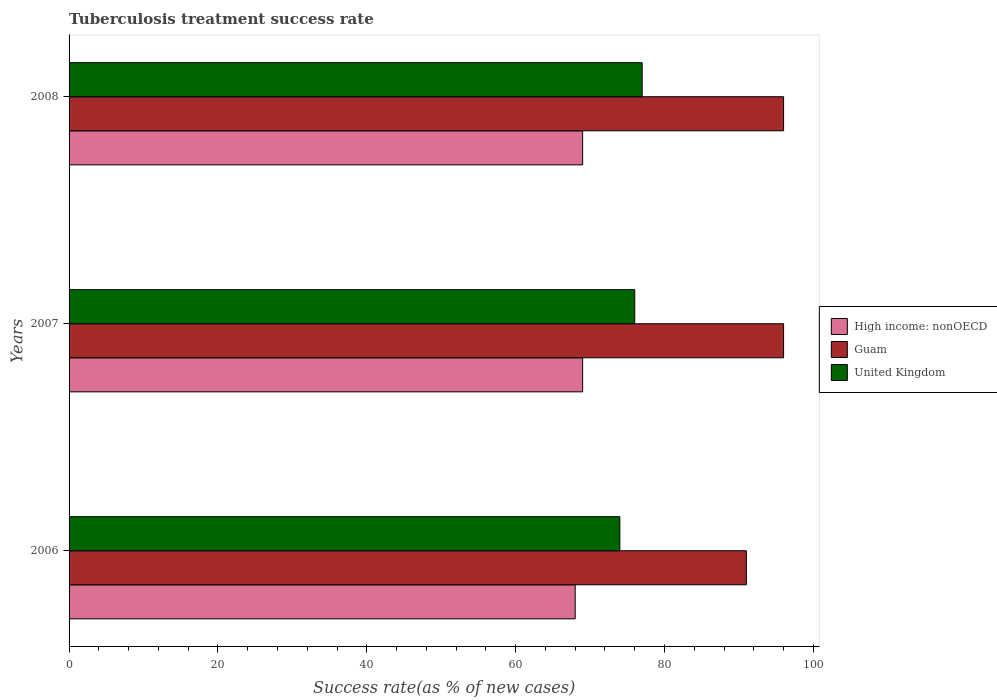How many groups of bars are there?
Ensure brevity in your answer.  3. Are the number of bars on each tick of the Y-axis equal?
Your response must be concise. Yes. How many bars are there on the 1st tick from the top?
Your response must be concise. 3. In how many cases, is the number of bars for a given year not equal to the number of legend labels?
Offer a very short reply. 0. What is the tuberculosis treatment success rate in United Kingdom in 2008?
Your answer should be compact. 77. Across all years, what is the maximum tuberculosis treatment success rate in High income: nonOECD?
Keep it short and to the point. 69. In which year was the tuberculosis treatment success rate in High income: nonOECD maximum?
Offer a very short reply. 2007. What is the total tuberculosis treatment success rate in High income: nonOECD in the graph?
Your response must be concise. 206. What is the average tuberculosis treatment success rate in Guam per year?
Offer a terse response. 94.33. In the year 2006, what is the difference between the tuberculosis treatment success rate in United Kingdom and tuberculosis treatment success rate in Guam?
Give a very brief answer. -17. What is the ratio of the tuberculosis treatment success rate in Guam in 2006 to that in 2007?
Provide a succinct answer. 0.95. Is the tuberculosis treatment success rate in High income: nonOECD in 2006 less than that in 2008?
Ensure brevity in your answer.  Yes. Is the sum of the tuberculosis treatment success rate in Guam in 2007 and 2008 greater than the maximum tuberculosis treatment success rate in United Kingdom across all years?
Your answer should be compact. Yes. What does the 2nd bar from the top in 2006 represents?
Ensure brevity in your answer.  Guam. What does the 2nd bar from the bottom in 2008 represents?
Keep it short and to the point. Guam. Is it the case that in every year, the sum of the tuberculosis treatment success rate in High income: nonOECD and tuberculosis treatment success rate in Guam is greater than the tuberculosis treatment success rate in United Kingdom?
Keep it short and to the point. Yes. How many bars are there?
Your response must be concise. 9. Are the values on the major ticks of X-axis written in scientific E-notation?
Make the answer very short. No. Where does the legend appear in the graph?
Your response must be concise. Center right. What is the title of the graph?
Your response must be concise. Tuberculosis treatment success rate. What is the label or title of the X-axis?
Make the answer very short. Success rate(as % of new cases). What is the Success rate(as % of new cases) of High income: nonOECD in 2006?
Provide a short and direct response. 68. What is the Success rate(as % of new cases) of Guam in 2006?
Your response must be concise. 91. What is the Success rate(as % of new cases) in United Kingdom in 2006?
Ensure brevity in your answer.  74. What is the Success rate(as % of new cases) of Guam in 2007?
Keep it short and to the point. 96. What is the Success rate(as % of new cases) of Guam in 2008?
Provide a succinct answer. 96. What is the Success rate(as % of new cases) of United Kingdom in 2008?
Offer a terse response. 77. Across all years, what is the maximum Success rate(as % of new cases) in Guam?
Make the answer very short. 96. Across all years, what is the maximum Success rate(as % of new cases) of United Kingdom?
Your answer should be compact. 77. Across all years, what is the minimum Success rate(as % of new cases) in High income: nonOECD?
Your answer should be very brief. 68. Across all years, what is the minimum Success rate(as % of new cases) in Guam?
Make the answer very short. 91. Across all years, what is the minimum Success rate(as % of new cases) of United Kingdom?
Offer a very short reply. 74. What is the total Success rate(as % of new cases) of High income: nonOECD in the graph?
Your response must be concise. 206. What is the total Success rate(as % of new cases) of Guam in the graph?
Provide a succinct answer. 283. What is the total Success rate(as % of new cases) in United Kingdom in the graph?
Your answer should be compact. 227. What is the difference between the Success rate(as % of new cases) in United Kingdom in 2006 and that in 2007?
Your response must be concise. -2. What is the difference between the Success rate(as % of new cases) in High income: nonOECD in 2006 and that in 2008?
Your answer should be very brief. -1. What is the difference between the Success rate(as % of new cases) in Guam in 2006 and that in 2008?
Provide a short and direct response. -5. What is the difference between the Success rate(as % of new cases) of Guam in 2007 and that in 2008?
Offer a very short reply. 0. What is the difference between the Success rate(as % of new cases) in United Kingdom in 2007 and that in 2008?
Your answer should be very brief. -1. What is the difference between the Success rate(as % of new cases) of Guam in 2006 and the Success rate(as % of new cases) of United Kingdom in 2007?
Provide a short and direct response. 15. What is the difference between the Success rate(as % of new cases) in High income: nonOECD in 2006 and the Success rate(as % of new cases) in United Kingdom in 2008?
Give a very brief answer. -9. What is the difference between the Success rate(as % of new cases) in High income: nonOECD in 2007 and the Success rate(as % of new cases) in Guam in 2008?
Make the answer very short. -27. What is the difference between the Success rate(as % of new cases) in Guam in 2007 and the Success rate(as % of new cases) in United Kingdom in 2008?
Keep it short and to the point. 19. What is the average Success rate(as % of new cases) in High income: nonOECD per year?
Ensure brevity in your answer.  68.67. What is the average Success rate(as % of new cases) of Guam per year?
Make the answer very short. 94.33. What is the average Success rate(as % of new cases) in United Kingdom per year?
Provide a succinct answer. 75.67. In the year 2006, what is the difference between the Success rate(as % of new cases) in High income: nonOECD and Success rate(as % of new cases) in United Kingdom?
Ensure brevity in your answer.  -6. In the year 2006, what is the difference between the Success rate(as % of new cases) in Guam and Success rate(as % of new cases) in United Kingdom?
Offer a very short reply. 17. In the year 2007, what is the difference between the Success rate(as % of new cases) in High income: nonOECD and Success rate(as % of new cases) in United Kingdom?
Your answer should be very brief. -7. In the year 2008, what is the difference between the Success rate(as % of new cases) in High income: nonOECD and Success rate(as % of new cases) in Guam?
Provide a short and direct response. -27. In the year 2008, what is the difference between the Success rate(as % of new cases) of High income: nonOECD and Success rate(as % of new cases) of United Kingdom?
Offer a very short reply. -8. In the year 2008, what is the difference between the Success rate(as % of new cases) of Guam and Success rate(as % of new cases) of United Kingdom?
Make the answer very short. 19. What is the ratio of the Success rate(as % of new cases) in High income: nonOECD in 2006 to that in 2007?
Your answer should be very brief. 0.99. What is the ratio of the Success rate(as % of new cases) in Guam in 2006 to that in 2007?
Offer a terse response. 0.95. What is the ratio of the Success rate(as % of new cases) in United Kingdom in 2006 to that in 2007?
Keep it short and to the point. 0.97. What is the ratio of the Success rate(as % of new cases) in High income: nonOECD in 2006 to that in 2008?
Give a very brief answer. 0.99. What is the ratio of the Success rate(as % of new cases) of Guam in 2006 to that in 2008?
Ensure brevity in your answer.  0.95. What is the ratio of the Success rate(as % of new cases) of High income: nonOECD in 2007 to that in 2008?
Provide a short and direct response. 1. What is the ratio of the Success rate(as % of new cases) in Guam in 2007 to that in 2008?
Offer a very short reply. 1. What is the difference between the highest and the second highest Success rate(as % of new cases) in High income: nonOECD?
Ensure brevity in your answer.  0. What is the difference between the highest and the second highest Success rate(as % of new cases) of Guam?
Keep it short and to the point. 0. What is the difference between the highest and the second highest Success rate(as % of new cases) of United Kingdom?
Ensure brevity in your answer.  1. What is the difference between the highest and the lowest Success rate(as % of new cases) in High income: nonOECD?
Offer a very short reply. 1. What is the difference between the highest and the lowest Success rate(as % of new cases) of United Kingdom?
Your answer should be very brief. 3. 